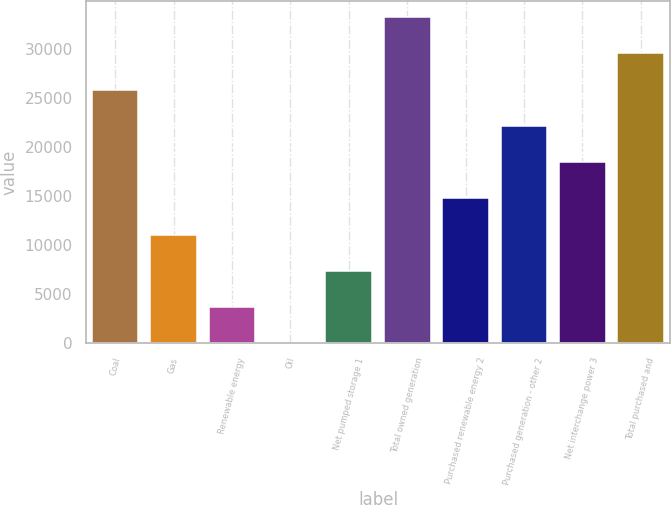Convert chart. <chart><loc_0><loc_0><loc_500><loc_500><bar_chart><fcel>Coal<fcel>Gas<fcel>Renewable energy<fcel>Oil<fcel>Net pumped storage 1<fcel>Total owned generation<fcel>Purchased renewable energy 2<fcel>Purchased generation - other 2<fcel>Net interchange power 3<fcel>Total purchased and<nl><fcel>25899.3<fcel>11111.7<fcel>3717.9<fcel>21<fcel>7414.8<fcel>33293.1<fcel>14808.6<fcel>22202.4<fcel>18505.5<fcel>29596.2<nl></chart> 